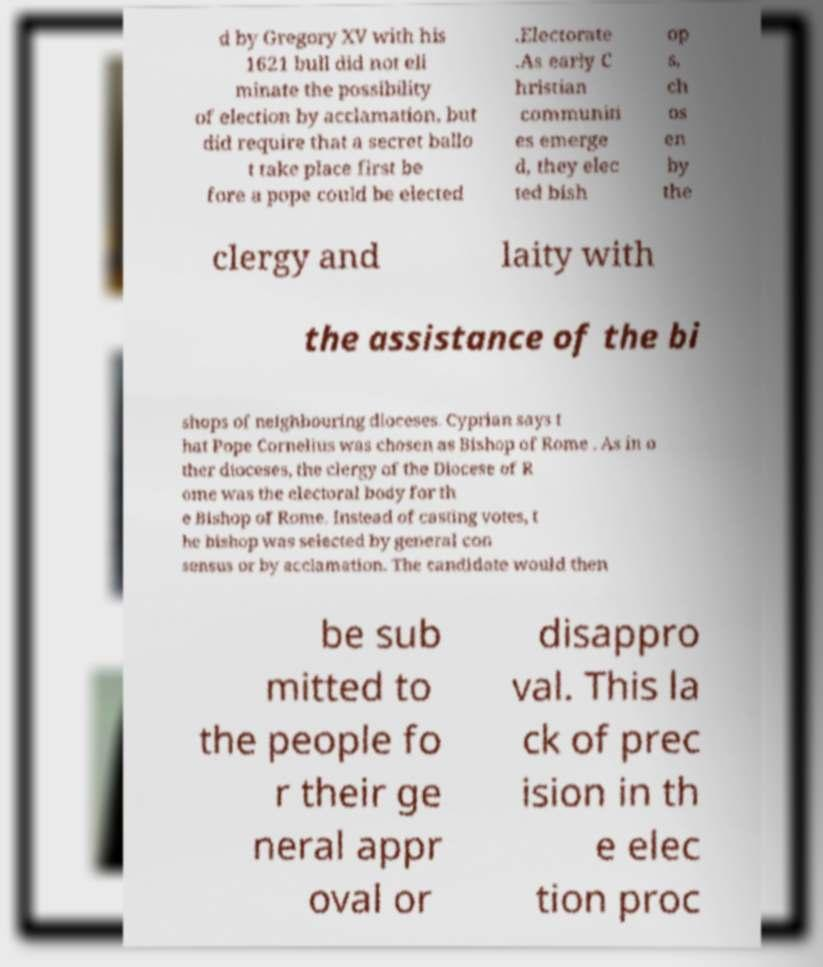What messages or text are displayed in this image? I need them in a readable, typed format. d by Gregory XV with his 1621 bull did not eli minate the possibility of election by acclamation, but did require that a secret ballo t take place first be fore a pope could be elected .Electorate .As early C hristian communiti es emerge d, they elec ted bish op s, ch os en by the clergy and laity with the assistance of the bi shops of neighbouring dioceses. Cyprian says t hat Pope Cornelius was chosen as Bishop of Rome . As in o ther dioceses, the clergy of the Diocese of R ome was the electoral body for th e Bishop of Rome. Instead of casting votes, t he bishop was selected by general con sensus or by acclamation. The candidate would then be sub mitted to the people fo r their ge neral appr oval or disappro val. This la ck of prec ision in th e elec tion proc 